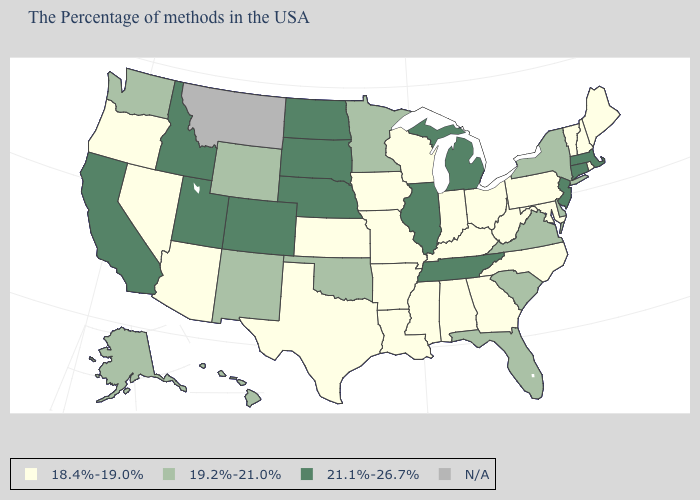What is the value of Louisiana?
Write a very short answer. 18.4%-19.0%. Name the states that have a value in the range 21.1%-26.7%?
Keep it brief. Massachusetts, Connecticut, New Jersey, Michigan, Tennessee, Illinois, Nebraska, South Dakota, North Dakota, Colorado, Utah, Idaho, California. What is the value of Massachusetts?
Short answer required. 21.1%-26.7%. What is the value of Kentucky?
Quick response, please. 18.4%-19.0%. Among the states that border Colorado , which have the lowest value?
Answer briefly. Kansas, Arizona. Name the states that have a value in the range 19.2%-21.0%?
Concise answer only. New York, Delaware, Virginia, South Carolina, Florida, Minnesota, Oklahoma, Wyoming, New Mexico, Washington, Alaska, Hawaii. What is the lowest value in the USA?
Quick response, please. 18.4%-19.0%. How many symbols are there in the legend?
Write a very short answer. 4. What is the value of Alaska?
Concise answer only. 19.2%-21.0%. What is the value of Missouri?
Write a very short answer. 18.4%-19.0%. What is the value of Illinois?
Give a very brief answer. 21.1%-26.7%. Name the states that have a value in the range 21.1%-26.7%?
Write a very short answer. Massachusetts, Connecticut, New Jersey, Michigan, Tennessee, Illinois, Nebraska, South Dakota, North Dakota, Colorado, Utah, Idaho, California. 